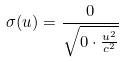<formula> <loc_0><loc_0><loc_500><loc_500>\sigma ( u ) = \frac { 0 } { \sqrt { 0 \cdot \frac { u ^ { 2 } } { c ^ { 2 } } } }</formula> 